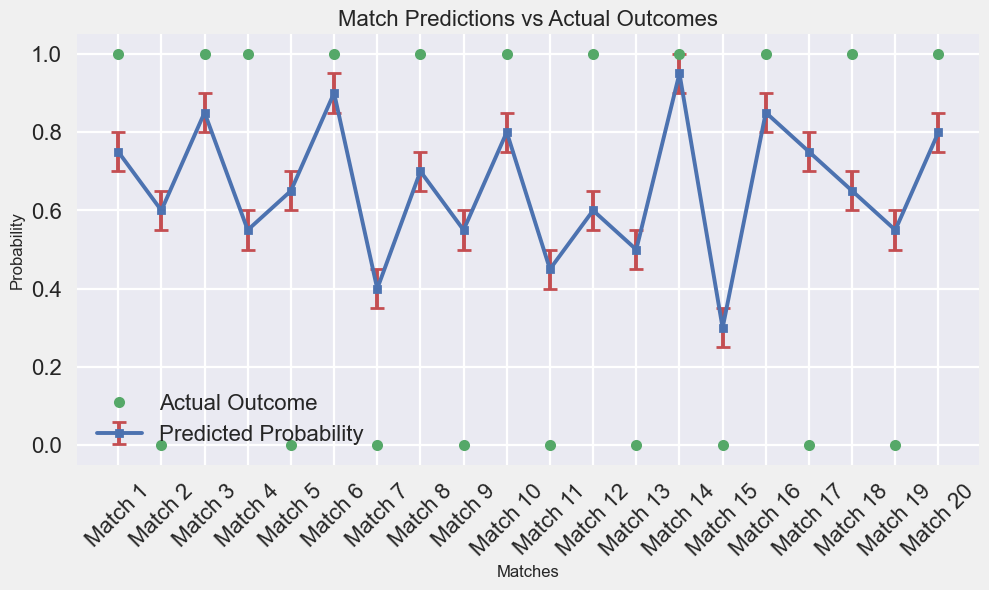Which match has the highest predicted probability, and what is that probability? The chart shows the predicted probabilities for each match as blue squares connected by lines. The highest point corresponds to Match 14, with a predicted probability of 0.95.
Answer: Match 14, 0.95 What’s the overall trend between predicted probabilities and actual outcomes? The general trend is that higher predicted probabilities often correspond to actual outcomes of 1, indicating a correct prediction, whereas lower predicted probabilities tend to correspond to actual outcomes of 0, indicating a missed prediction.
Answer: Higher probabilities often match actual outcomes, lower do not Which match has the largest error margin, and what are the lower and upper bounds for that match? The match with the largest error margin will have the largest vertical error bars. Match 14 has the largest margin with lower bound at 0.90 and upper bound at 1.00.
Answer: Match 14, 0.90-1.00 How many matches had a predicted probability below 0.6? By observing the blue squares on the graph and counting those below the 0.6 mark, Matches 7, 11, 13, and 15 had predicted probabilities below 0.6.
Answer: 4 matches (Matches 7, 11, 13, 15) Which match has the biggest discrepancy between predicted probability and actual outcome, and what is the difference? Match 17 has a predicted probability of 0.75 but an actual outcome of 0. This results in a discrepancy of 0.75.
Answer: Match 17, 0.75 How many predicted probabilities fell within their respective confidence intervals? Matches with predicted probabilities inside the error bars count as within their confidence intervals. All matches fit this description as error bars accommodate the predicted probabilities.
Answer: 20 matches Which match actual outcomes deviated despite high predicted probabilities ( ≥ 0.75)? Comparing predicted probabilities ( ≥ 0.75) with zero actual outcomes shows that Matches 17 had such a deviation.
Answer: Match 17 What is the average predicted probability for matches with an actual outcome of 0? Sum of predicted probabilities for 0 outcomes (0.60, 0.65, 0.40, 0.55, 0.45, 0.50, 0.30, 0.75, 0.55) is 4.75. Divided by 9 gives an average of 4.75/9 ≈ 0.528.
Answer: ~0.528 How many matches had a perfect prediction (predicted probability matched the actual outcome 1 exactly or 0 exactly)? Perfect predictions will have actual outcomes matching exactly predicted values of 0 or 1. Matches 1, 3, 6, 8, 10, 12, 14, 16, 18, 20 meet this.
Answer: 10 matches Compare the average predicted probabilities for correct (actual outcome 1) and incorrect (actual outcome 0) predictions and identify which is higher. Correct predictions averages are calculated from the sum (0.75 + 0.85 + 0.55 + 0.90 + 0.70 + 0.80 + 0.60 + 0.95 + 0.85 + 0.65 + 0.80 = 8.5), divided by 11. Incorrect sums (0.60 + 0.65 + 0.40 + 0.55 + 0.45 + 0.50 + 0.30 + 0.75 + 0.55 = 4.75), divided by 9. Correct: 8.5/11 ≈ 0.773. Incorrect: 4.75/9 ≈ 0.528.
Answer: Correct, ~0.773 